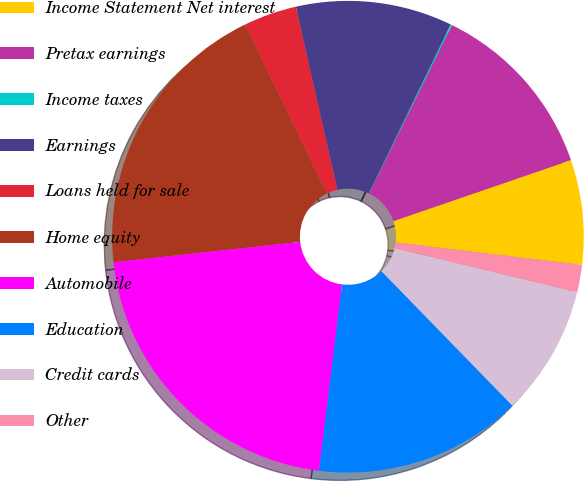Convert chart to OTSL. <chart><loc_0><loc_0><loc_500><loc_500><pie_chart><fcel>Income Statement Net interest<fcel>Pretax earnings<fcel>Income taxes<fcel>Earnings<fcel>Loans held for sale<fcel>Home equity<fcel>Automobile<fcel>Education<fcel>Credit cards<fcel>Other<nl><fcel>7.17%<fcel>12.47%<fcel>0.1%<fcel>10.71%<fcel>3.64%<fcel>19.54%<fcel>21.31%<fcel>14.24%<fcel>8.94%<fcel>1.87%<nl></chart> 